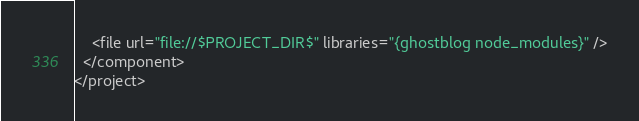Convert code to text. <code><loc_0><loc_0><loc_500><loc_500><_XML_>    <file url="file://$PROJECT_DIR$" libraries="{ghostblog node_modules}" />
  </component>
</project></code> 